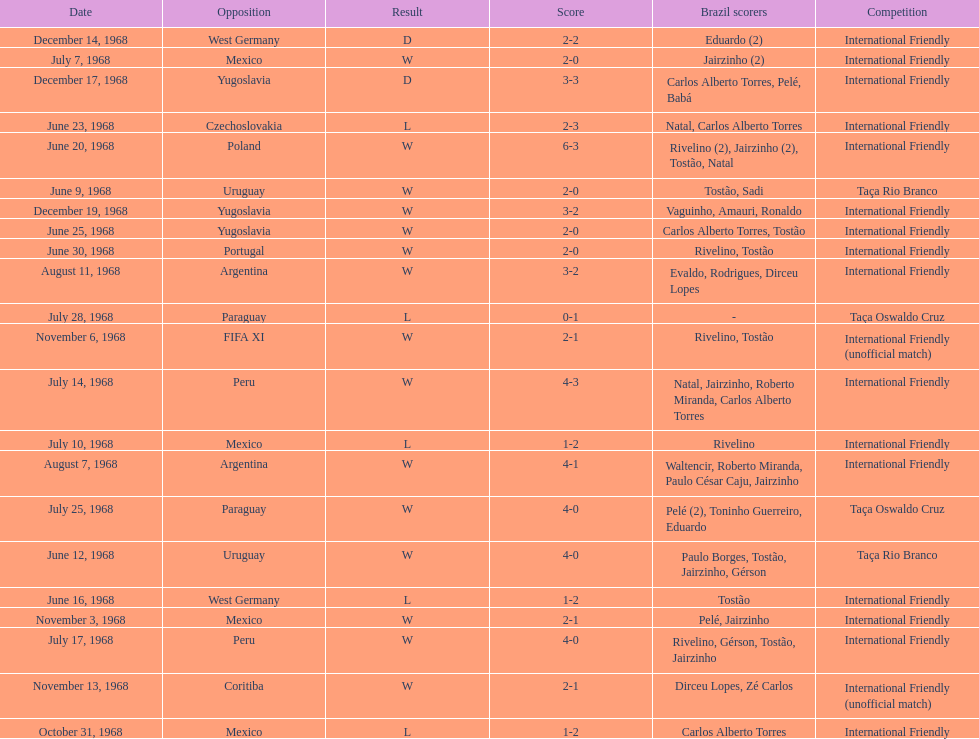What is the number of countries they have played? 11. 